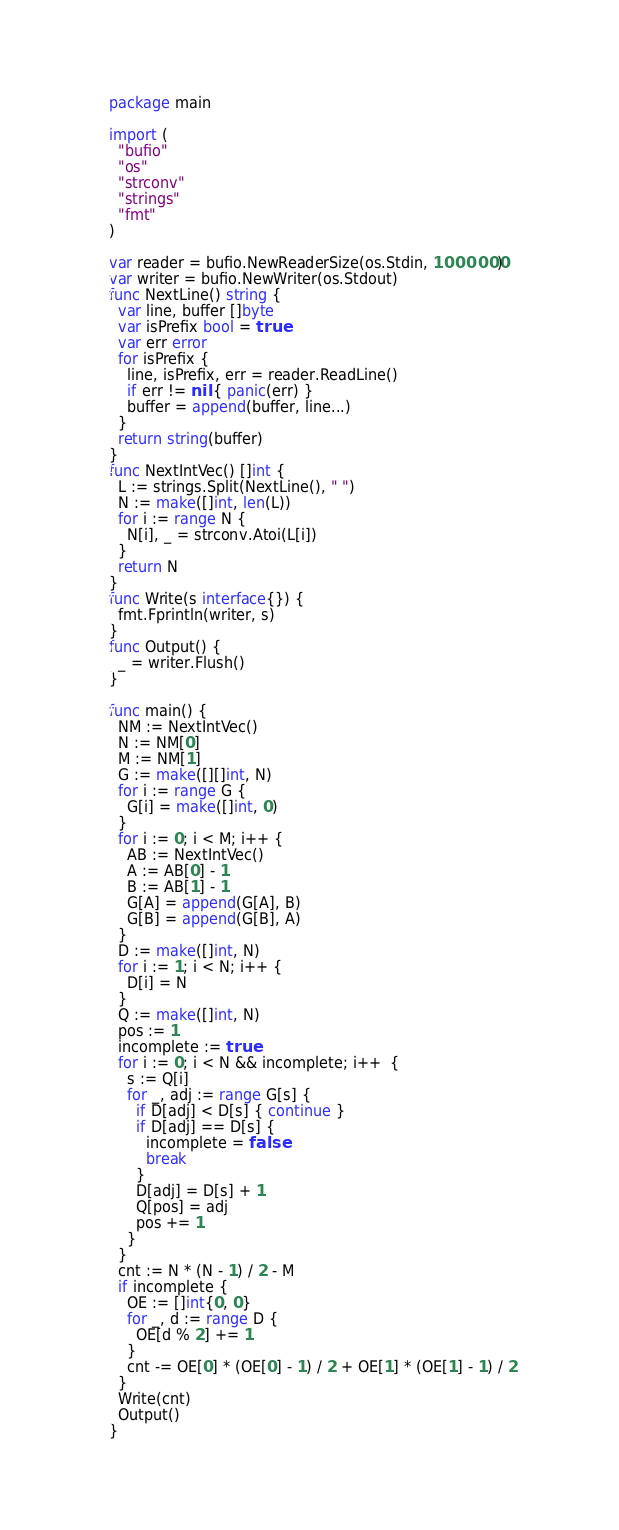Convert code to text. <code><loc_0><loc_0><loc_500><loc_500><_Go_>package main

import (
  "bufio"
  "os"
  "strconv"
  "strings"
  "fmt"
)

var reader = bufio.NewReaderSize(os.Stdin, 1000000)
var writer = bufio.NewWriter(os.Stdout)
func NextLine() string {
  var line, buffer []byte
  var isPrefix bool = true
  var err error
  for isPrefix {
    line, isPrefix, err = reader.ReadLine()
    if err != nil { panic(err) }
    buffer = append(buffer, line...)
  }
  return string(buffer)
}
func NextIntVec() []int {
  L := strings.Split(NextLine(), " ")
  N := make([]int, len(L))
  for i := range N {
    N[i], _ = strconv.Atoi(L[i])
  }
  return N
}
func Write(s interface{}) {
  fmt.Fprintln(writer, s)
}
func Output() {
  _ = writer.Flush()
}

func main() {
  NM := NextIntVec()
  N := NM[0]
  M := NM[1]
  G := make([][]int, N)
  for i := range G {
    G[i] = make([]int, 0)
  }
  for i := 0; i < M; i++ {
    AB := NextIntVec()
    A := AB[0] - 1
    B := AB[1] - 1
    G[A] = append(G[A], B)
    G[B] = append(G[B], A)
  }
  D := make([]int, N)
  for i := 1; i < N; i++ {
    D[i] = N
  }
  Q := make([]int, N)
  pos := 1
  incomplete := true
  for i := 0; i < N && incomplete; i++  {
    s := Q[i]
    for _, adj := range G[s] {
      if D[adj] < D[s] { continue }
      if D[adj] == D[s] {
        incomplete = false
        break
      }
      D[adj] = D[s] + 1
      Q[pos] = adj
      pos += 1
    }
  }
  cnt := N * (N - 1) / 2 - M
  if incomplete {
  	OE := []int{0, 0}
  	for _, d := range D {
      OE[d % 2] += 1
  	}
    cnt -= OE[0] * (OE[0] - 1) / 2 + OE[1] * (OE[1] - 1) / 2  
  }
  Write(cnt)
  Output()
}</code> 